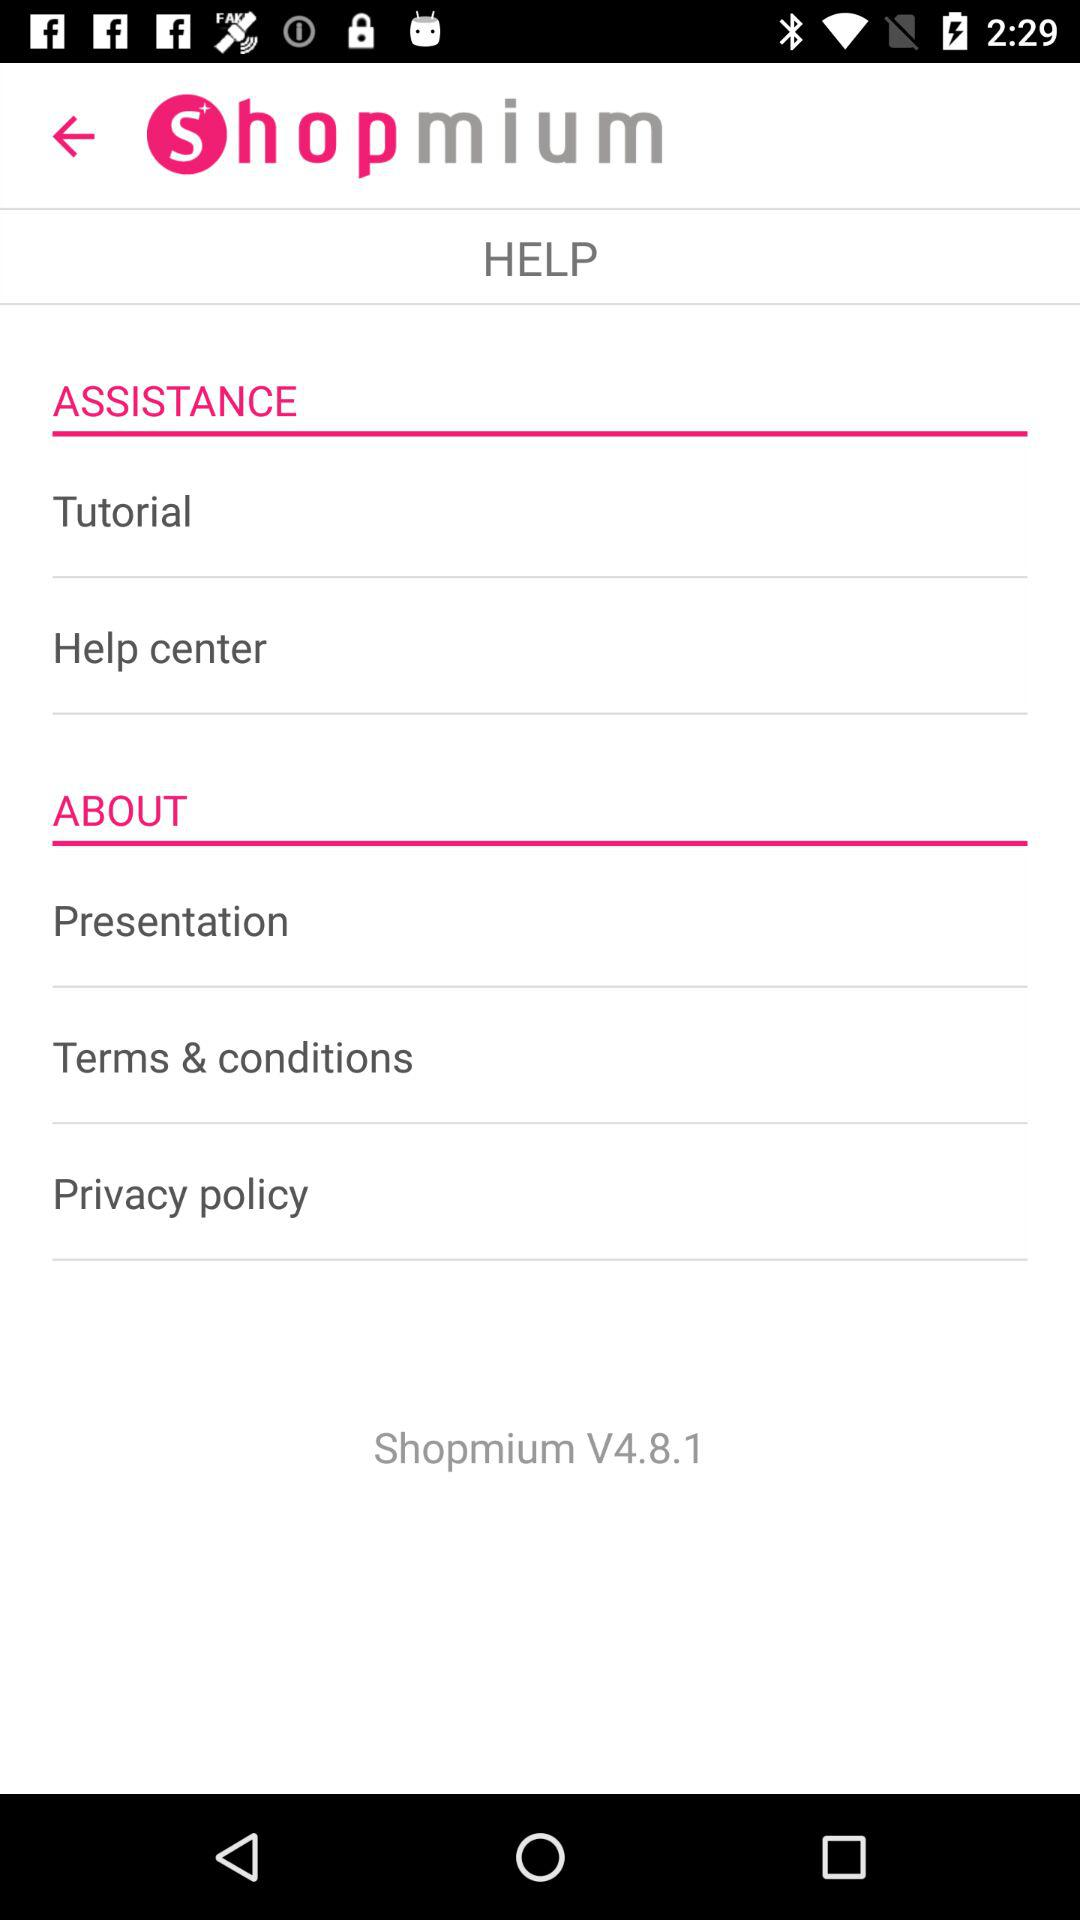What is the name of the application? The name of the application is "Shopmium". 